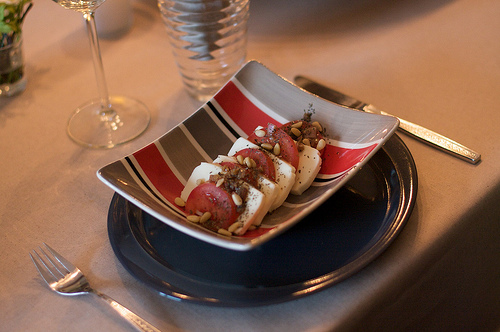<image>
Is there a bowl on the table? Yes. Looking at the image, I can see the bowl is positioned on top of the table, with the table providing support. 